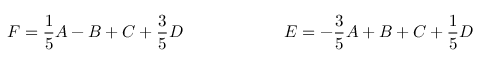Convert formula to latex. <formula><loc_0><loc_0><loc_500><loc_500>F = \frac { 1 } { 5 } A - B + C + \frac { 3 } { 5 } D \quad E = - \frac { 3 } { 5 } A + B + C + \frac { 1 } { 5 } D</formula> 